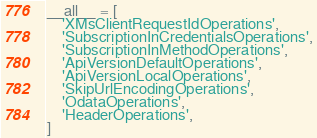Convert code to text. <code><loc_0><loc_0><loc_500><loc_500><_Python_>
__all__ = [
    'XMsClientRequestIdOperations',
    'SubscriptionInCredentialsOperations',
    'SubscriptionInMethodOperations',
    'ApiVersionDefaultOperations',
    'ApiVersionLocalOperations',
    'SkipUrlEncodingOperations',
    'OdataOperations',
    'HeaderOperations',
]
</code> 